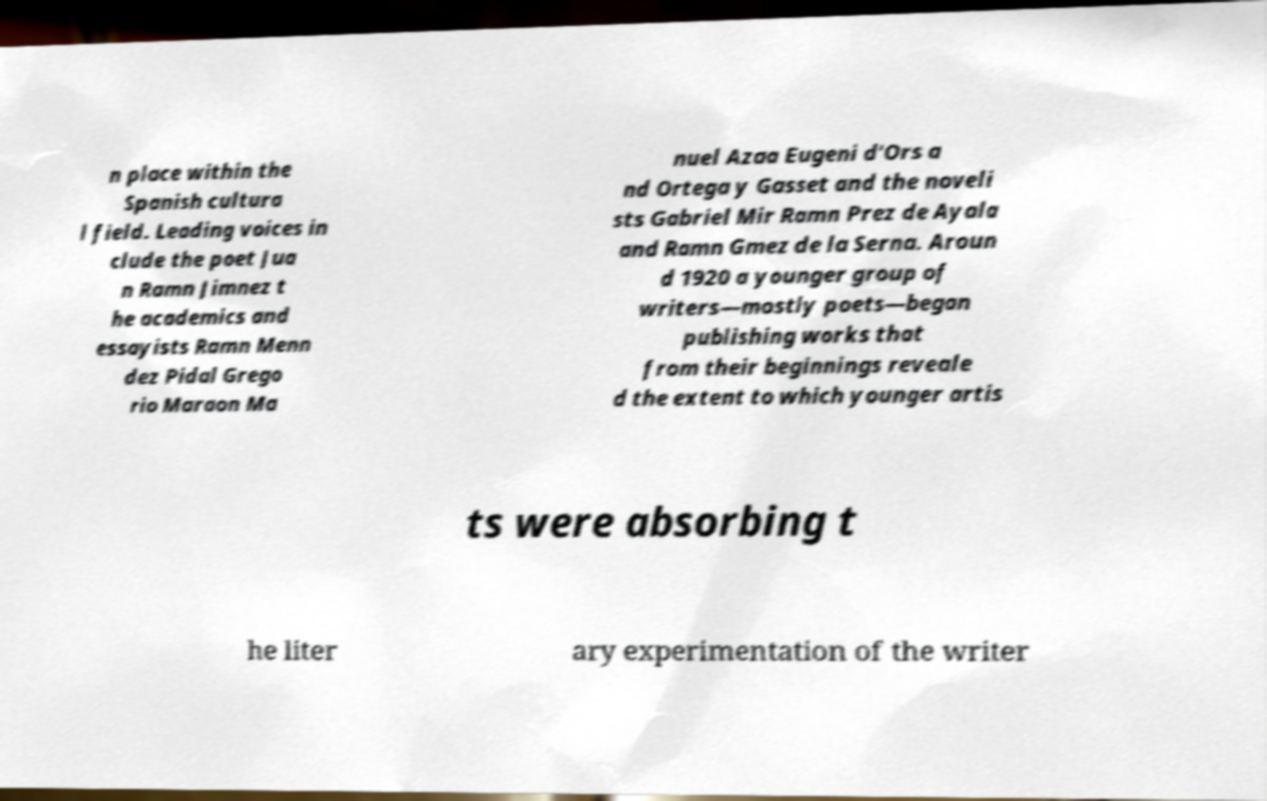What messages or text are displayed in this image? I need them in a readable, typed format. n place within the Spanish cultura l field. Leading voices in clude the poet Jua n Ramn Jimnez t he academics and essayists Ramn Menn dez Pidal Grego rio Maraon Ma nuel Azaa Eugeni d'Ors a nd Ortega y Gasset and the noveli sts Gabriel Mir Ramn Prez de Ayala and Ramn Gmez de la Serna. Aroun d 1920 a younger group of writers—mostly poets—began publishing works that from their beginnings reveale d the extent to which younger artis ts were absorbing t he liter ary experimentation of the writer 